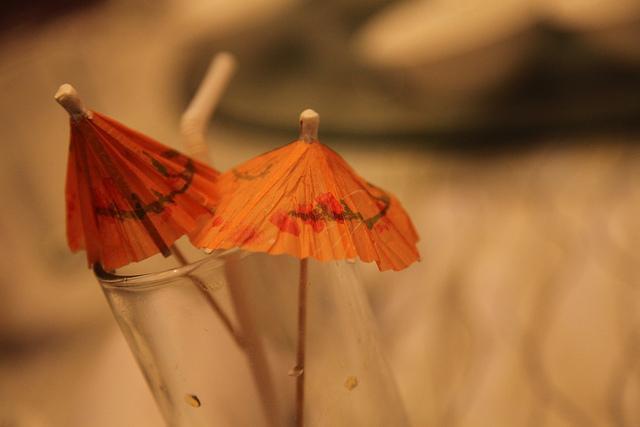How many umbrellas are visible?
Give a very brief answer. 2. 